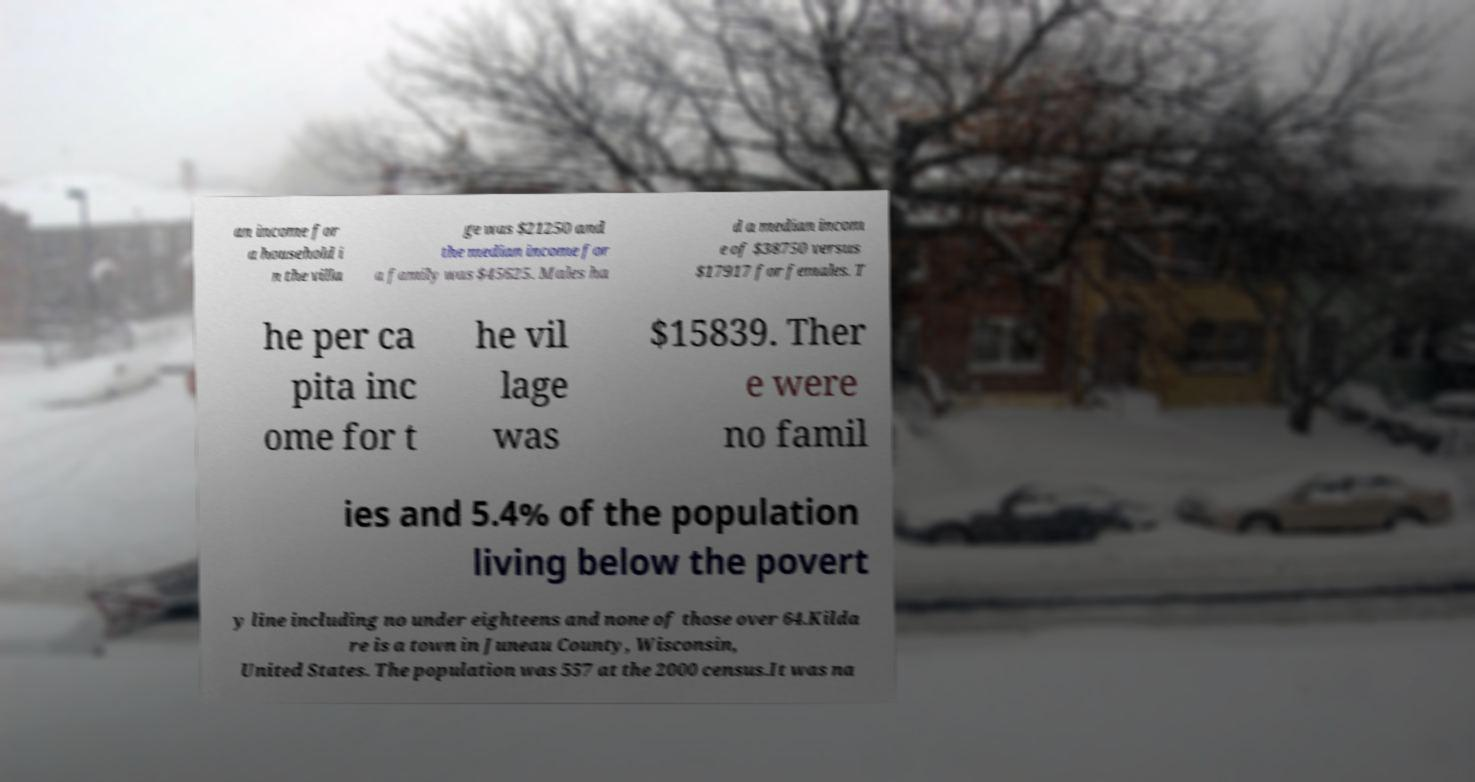Can you accurately transcribe the text from the provided image for me? an income for a household i n the villa ge was $21250 and the median income for a family was $45625. Males ha d a median incom e of $38750 versus $17917 for females. T he per ca pita inc ome for t he vil lage was $15839. Ther e were no famil ies and 5.4% of the population living below the povert y line including no under eighteens and none of those over 64.Kilda re is a town in Juneau County, Wisconsin, United States. The population was 557 at the 2000 census.It was na 